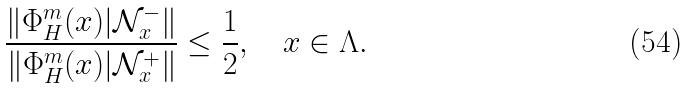Convert formula to latex. <formula><loc_0><loc_0><loc_500><loc_500>\frac { \| \Phi ^ { m } _ { H } ( x ) | \mathcal { N } ^ { - } _ { x } \| } { \| \Phi ^ { m } _ { H } ( x ) | \mathcal { N } ^ { + } _ { x } \| } \leq { \frac { 1 } { 2 } } , \quad x \in \Lambda .</formula> 